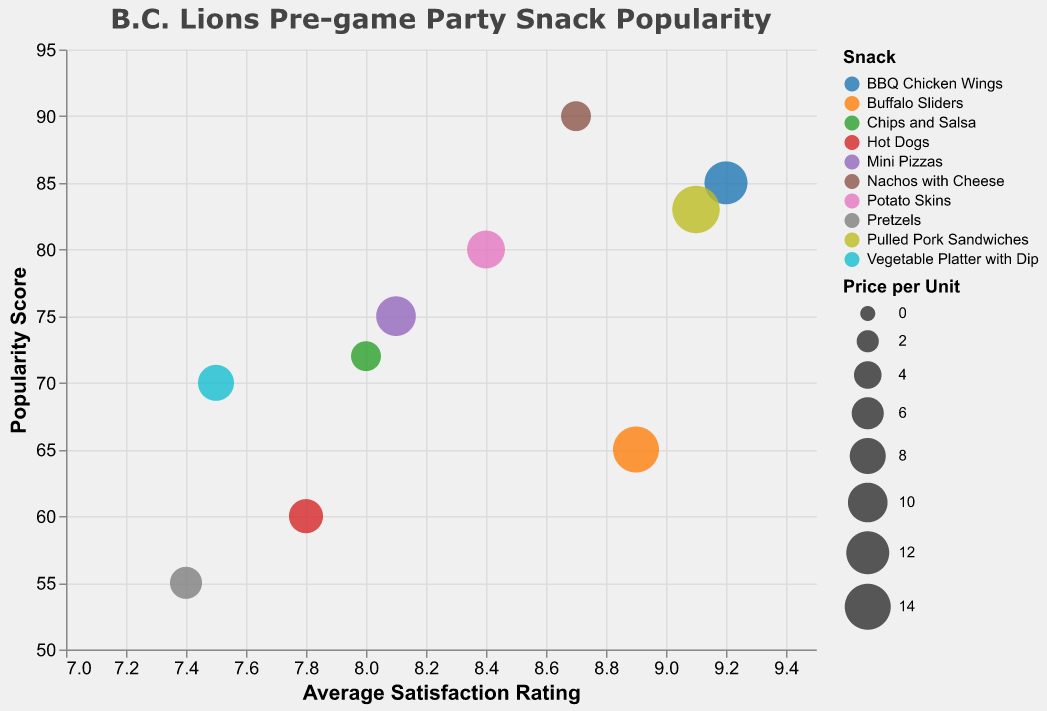What is the title of the figure? The title of the figure is provided directly above the chart.
Answer: "B.C. Lions Pre-game Party Snack Popularity" How many different types of snacks are shown in the figure? The legend or the number of differently colored circles representing each snack shows the number of types of snacks.
Answer: 10 Which snack has the highest average satisfaction rating? By looking at the x-axis, the snack with the furthest right position on the scale has the highest average rating. That's BBQ Chicken Wings.
Answer: BBQ Chicken Wings Which snack is the most popular? By checking the y-axis, the snack with the highest position denotes the most popular snack. That's Nachos with Cheese.
Answer: Nachos with Cheese What is the lowest satisfaction rating? The x-axis shows the average satisfaction ratings. The circle that is furthest to the left denotes the lowest rating. That's Pretzels with a satisfaction rating of 7.4.
Answer: 7.4 Which snack is both expensive and highly popular? Look for snacks that have large bubble sizes (indicating price) situated high on the y-axis (indicating popularity). Pulled Pork Sandwiches fits this criteria.
Answer: Pulled Pork Sandwiches What is the difference in popularity between the most expensive and least expensive snack? Identifying the most expensive snack, Pulled Pork Sandwiches ($15), and the least expensive snacks, Nachos with Cheese and Chips and Salsa ($5); then, looking at their y-axis positions for popularity. Pulled Pork Sandwiches has a popularity of 83 and Nachos with Cheese has a popularity of 90. 90 - 83 = 7. Chips and Salsa has a popularity of 72. 72 - 83 = 11.
Answer: 7 or 11, depending on comparison with Nachos with Cheese or Chips and Salsa Which snacks have an average satisfaction rating above 8.5? Check the x-axis for snacks positioned to the right of 8.5. These are Nachos with Cheese, BBQ Chicken Wings, Buffalo Sliders, and Pulled Pork Sandwiches.
Answer: Nachos with Cheese, BBQ Chicken Wings, Buffalo Sliders, Pulled Pork Sandwiches Is there a correlation between the price per unit and the popularity of the snacks? By examining bubble sizes and their positions on the y-axis, one can see whether there's a trend. More expensive snacks do not generally correlate with higher popularity in this chart. For instance, Pulled Pork Sandwiches are popular and expensive, but Pretzels are cheap and less popular.
Answer: No clear correlation Which snack costs around $10 and has higher than average satisfaction? Identify which bubble size (indicative of price) is around average and then cross-reference with its x-axis position for higher average satisfaction. Mini Pizzas are around $10 and have a satisfaction rating just above 8 (which is about average).
Answer: Mini Pizzas 